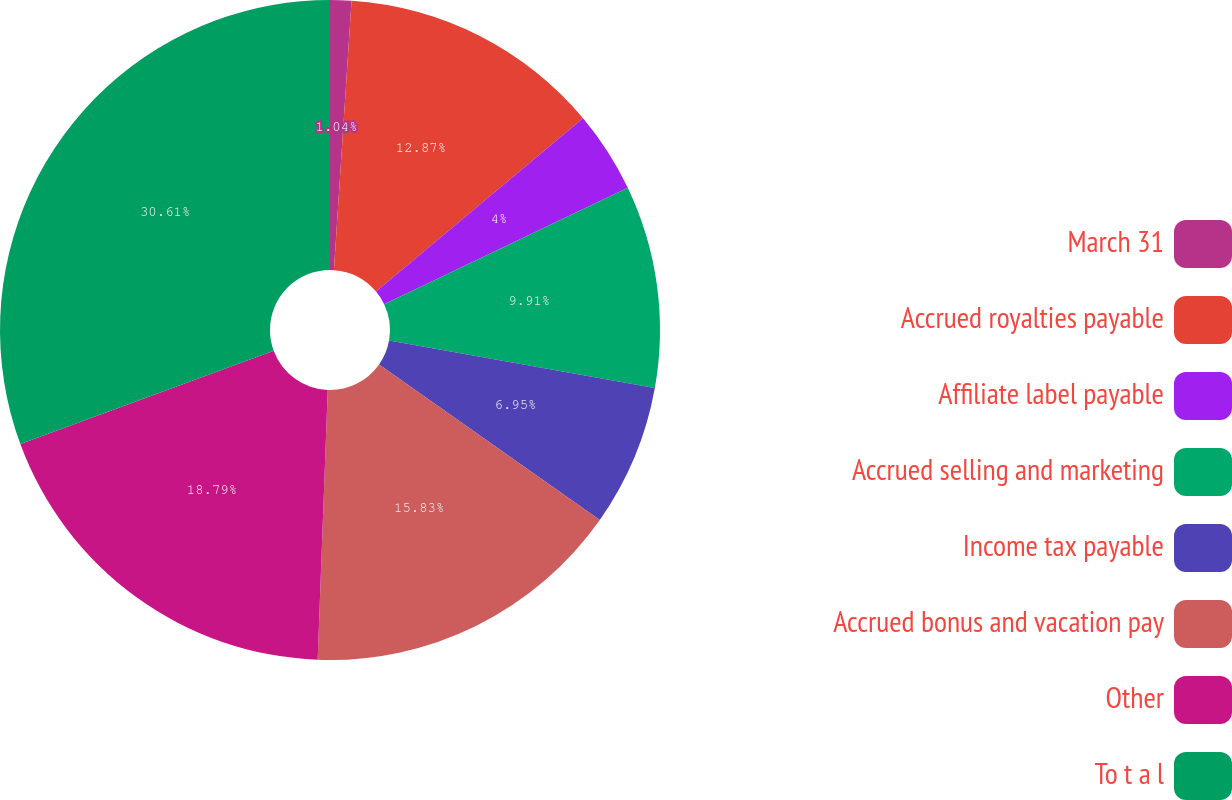<chart> <loc_0><loc_0><loc_500><loc_500><pie_chart><fcel>March 31<fcel>Accrued royalties payable<fcel>Affiliate label payable<fcel>Accrued selling and marketing<fcel>Income tax payable<fcel>Accrued bonus and vacation pay<fcel>Other<fcel>To t a l<nl><fcel>1.04%<fcel>12.87%<fcel>4.0%<fcel>9.91%<fcel>6.95%<fcel>15.83%<fcel>18.79%<fcel>30.62%<nl></chart> 